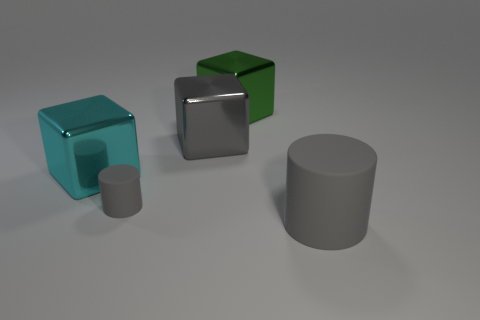Subtract all purple cylinders. Subtract all red cubes. How many cylinders are left? 2 Add 4 big gray matte things. How many objects exist? 9 Subtract all blocks. How many objects are left? 2 Add 5 big cyan blocks. How many big cyan blocks are left? 6 Add 3 large gray things. How many large gray things exist? 5 Subtract 0 yellow balls. How many objects are left? 5 Subtract all big rubber things. Subtract all small brown objects. How many objects are left? 4 